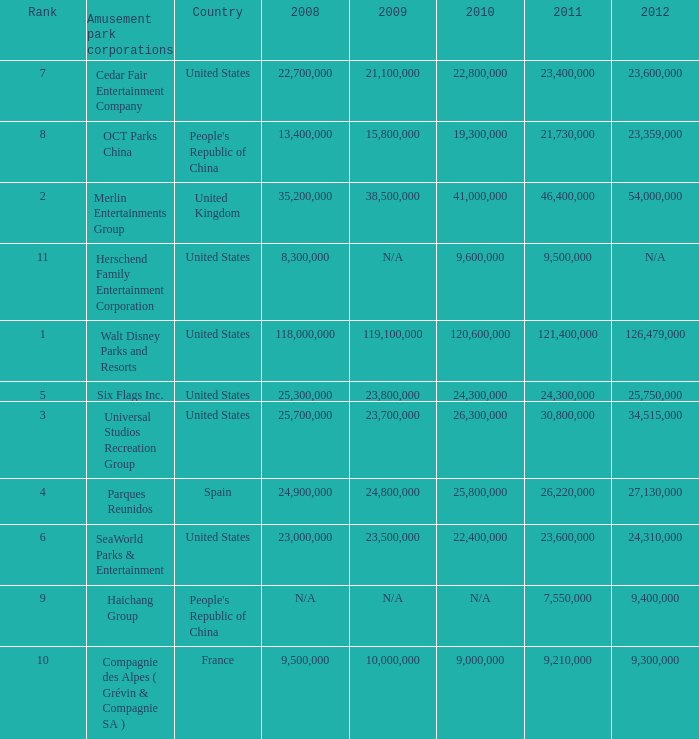In the United States the 2011 attendance at this amusement park corporation was larger than 30,800,000 but lists what as its 2008 attendance? 118000000.0. 